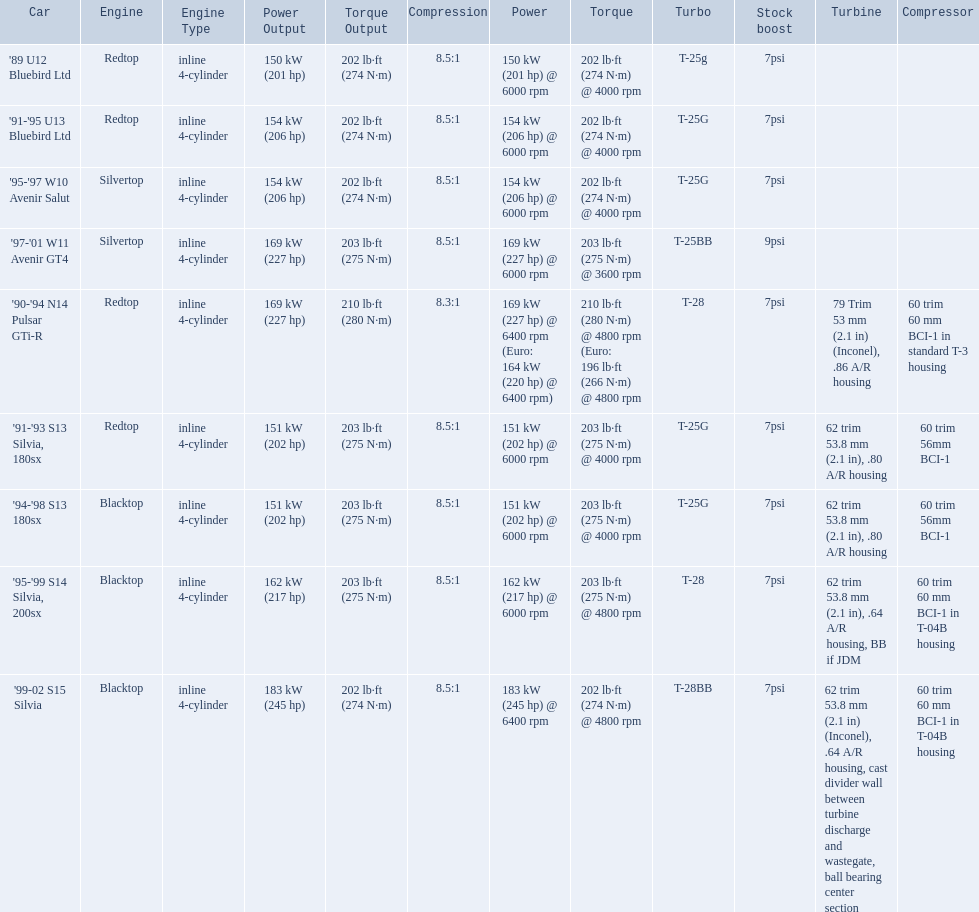Can you give me this table as a dict? {'header': ['Car', 'Engine', 'Engine Type', 'Power Output', 'Torque Output', 'Compression', 'Power', 'Torque', 'Turbo', 'Stock boost', 'Turbine', 'Compressor'], 'rows': [["'89 U12 Bluebird Ltd", 'Redtop', 'inline 4-cylinder', '150 kW (201 hp)', '202 lb·ft (274 N·m)', '8.5:1', '150\xa0kW (201\xa0hp) @ 6000 rpm', '202\xa0lb·ft (274\xa0N·m) @ 4000 rpm', 'T-25g', '7psi', '', ''], ["'91-'95 U13 Bluebird Ltd", 'Redtop', 'inline 4-cylinder', '154 kW (206 hp)', '202 lb·ft (274 N·m)', '8.5:1', '154\xa0kW (206\xa0hp) @ 6000 rpm', '202\xa0lb·ft (274\xa0N·m) @ 4000 rpm', 'T-25G', '7psi', '', ''], ["'95-'97 W10 Avenir Salut", 'Silvertop', 'inline 4-cylinder', '154 kW (206 hp)', '202 lb·ft (274 N·m)', '8.5:1', '154\xa0kW (206\xa0hp) @ 6000 rpm', '202\xa0lb·ft (274\xa0N·m) @ 4000 rpm', 'T-25G', '7psi', '', ''], ["'97-'01 W11 Avenir GT4", 'Silvertop', 'inline 4-cylinder', '169 kW (227 hp)', '203 lb·ft (275 N·m)', '8.5:1', '169\xa0kW (227\xa0hp) @ 6000 rpm', '203\xa0lb·ft (275\xa0N·m) @ 3600 rpm', 'T-25BB', '9psi', '', ''], ["'90-'94 N14 Pulsar GTi-R", 'Redtop', 'inline 4-cylinder', '169 kW (227 hp)', '210 lb·ft (280 N·m)', '8.3:1', '169\xa0kW (227\xa0hp) @ 6400 rpm (Euro: 164\xa0kW (220\xa0hp) @ 6400 rpm)', '210\xa0lb·ft (280\xa0N·m) @ 4800 rpm (Euro: 196\xa0lb·ft (266\xa0N·m) @ 4800 rpm', 'T-28', '7psi', '79 Trim 53\xa0mm (2.1\xa0in) (Inconel), .86 A/R housing', '60 trim 60\xa0mm BCI-1 in standard T-3 housing'], ["'91-'93 S13 Silvia, 180sx", 'Redtop', 'inline 4-cylinder', '151 kW (202 hp)', '203 lb·ft (275 N·m)', '8.5:1', '151\xa0kW (202\xa0hp) @ 6000 rpm', '203\xa0lb·ft (275\xa0N·m) @ 4000 rpm', 'T-25G', '7psi', '62 trim 53.8\xa0mm (2.1\xa0in), .80 A/R housing', '60 trim 56mm BCI-1'], ["'94-'98 S13 180sx", 'Blacktop', 'inline 4-cylinder', '151 kW (202 hp)', '203 lb·ft (275 N·m)', '8.5:1', '151\xa0kW (202\xa0hp) @ 6000 rpm', '203\xa0lb·ft (275\xa0N·m) @ 4000 rpm', 'T-25G', '7psi', '62 trim 53.8\xa0mm (2.1\xa0in), .80 A/R housing', '60 trim 56mm BCI-1'], ["'95-'99 S14 Silvia, 200sx", 'Blacktop', 'inline 4-cylinder', '162 kW (217 hp)', '203 lb·ft (275 N·m)', '8.5:1', '162\xa0kW (217\xa0hp) @ 6000 rpm', '203\xa0lb·ft (275\xa0N·m) @ 4800 rpm', 'T-28', '7psi', '62 trim 53.8\xa0mm (2.1\xa0in), .64 A/R housing, BB if JDM', '60 trim 60\xa0mm BCI-1 in T-04B housing'], ["'99-02 S15 Silvia", 'Blacktop', 'inline 4-cylinder', '183 kW (245 hp)', '202 lb·ft (274 N·m)', '8.5:1', '183\xa0kW (245\xa0hp) @ 6400 rpm', '202\xa0lb·ft (274\xa0N·m) @ 4800 rpm', 'T-28BB', '7psi', '62 trim 53.8\xa0mm (2.1\xa0in) (Inconel), .64 A/R housing, cast divider wall between turbine discharge and wastegate, ball bearing center section', '60 trim 60\xa0mm BCI-1 in T-04B housing']]} What are the psi's? 7psi, 7psi, 7psi, 9psi, 7psi, 7psi, 7psi, 7psi, 7psi. What are the number(s) greater than 7? 9psi. Which car has that number? '97-'01 W11 Avenir GT4. 